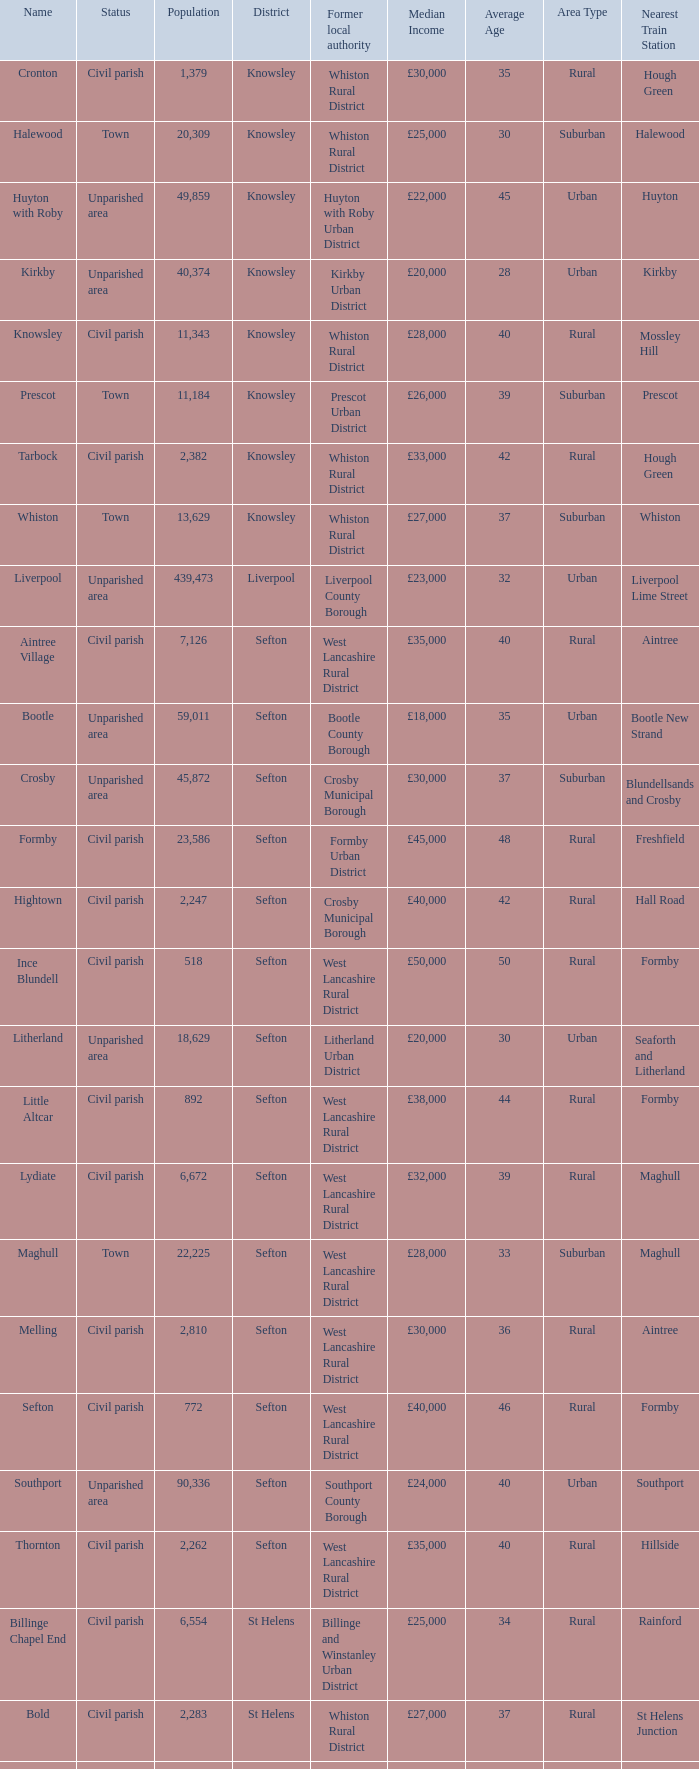What is the district of wallasey Wirral. 